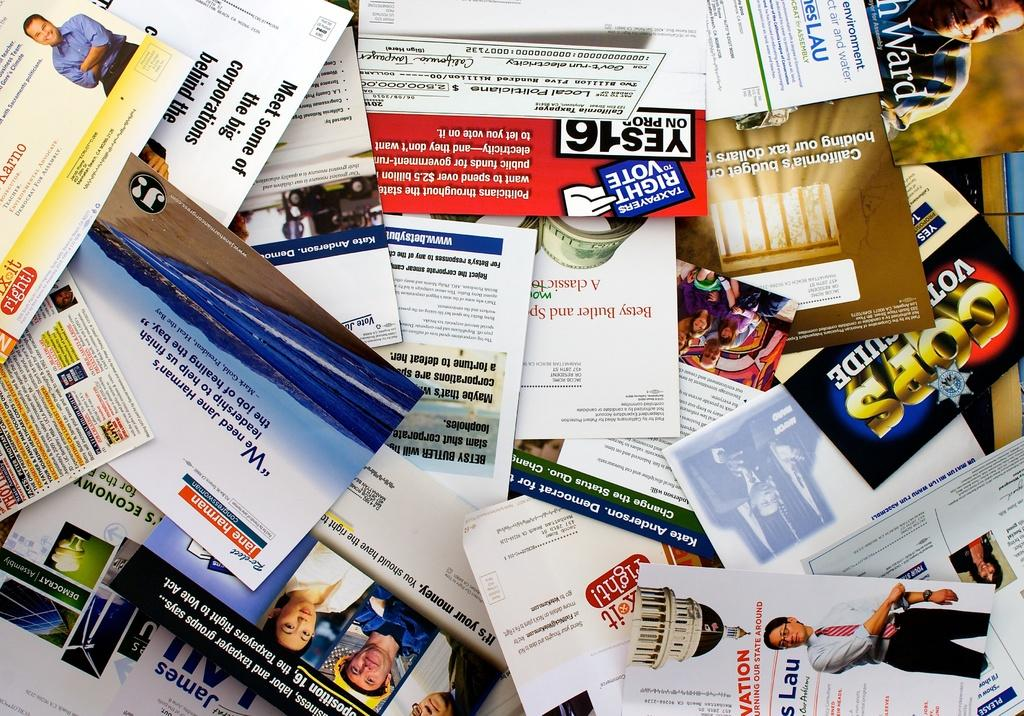What type of printed material is visible in the image? There are pamphlets in the image. How are the pamphlets arranged in the image? The pamphlets are stacked one upon the other. What can be seen on the surface of the pamphlets? There are pictures, letters, and logos on the pamphlets. Can you see the father helping with the pamphlets in the image? There is no reference to a father or any helping activity in the image; it only shows stacked pamphlets with pictures, letters, and logos. 